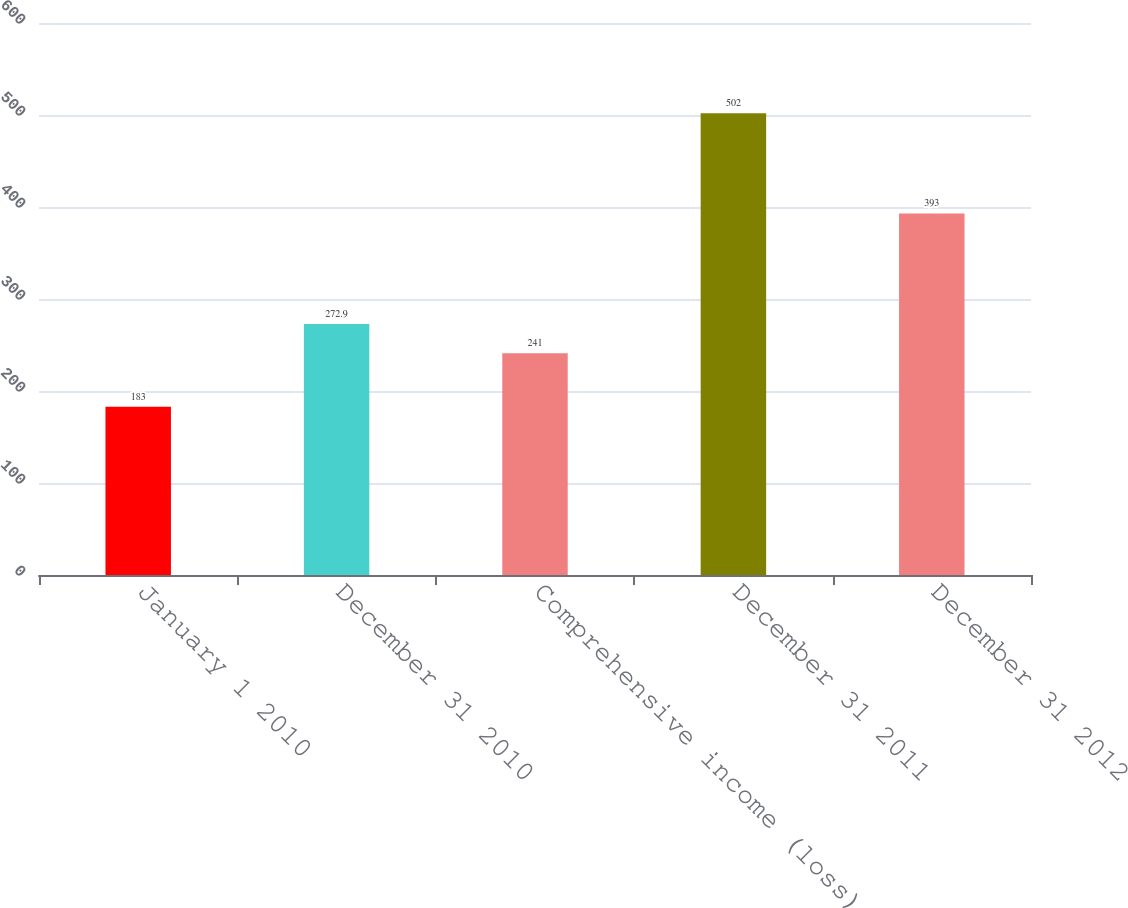Convert chart to OTSL. <chart><loc_0><loc_0><loc_500><loc_500><bar_chart><fcel>January 1 2010<fcel>December 31 2010<fcel>Comprehensive income (loss)<fcel>December 31 2011<fcel>December 31 2012<nl><fcel>183<fcel>272.9<fcel>241<fcel>502<fcel>393<nl></chart> 